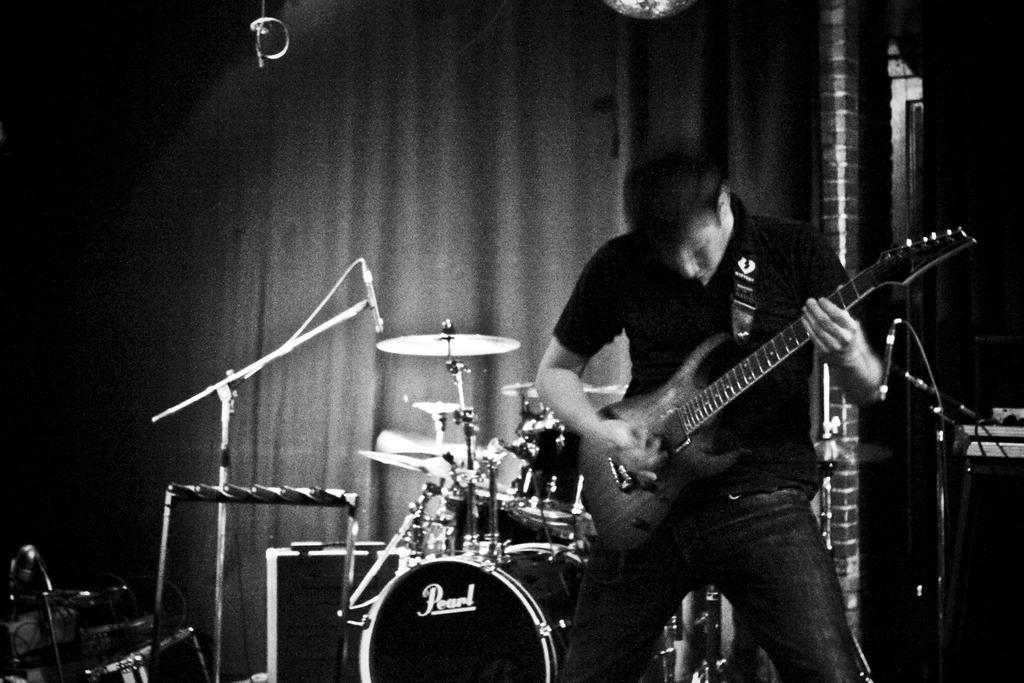How would you summarize this image in a sentence or two? In this picture we can see one person is playing guitar, behind we can see so many musical instruments. 